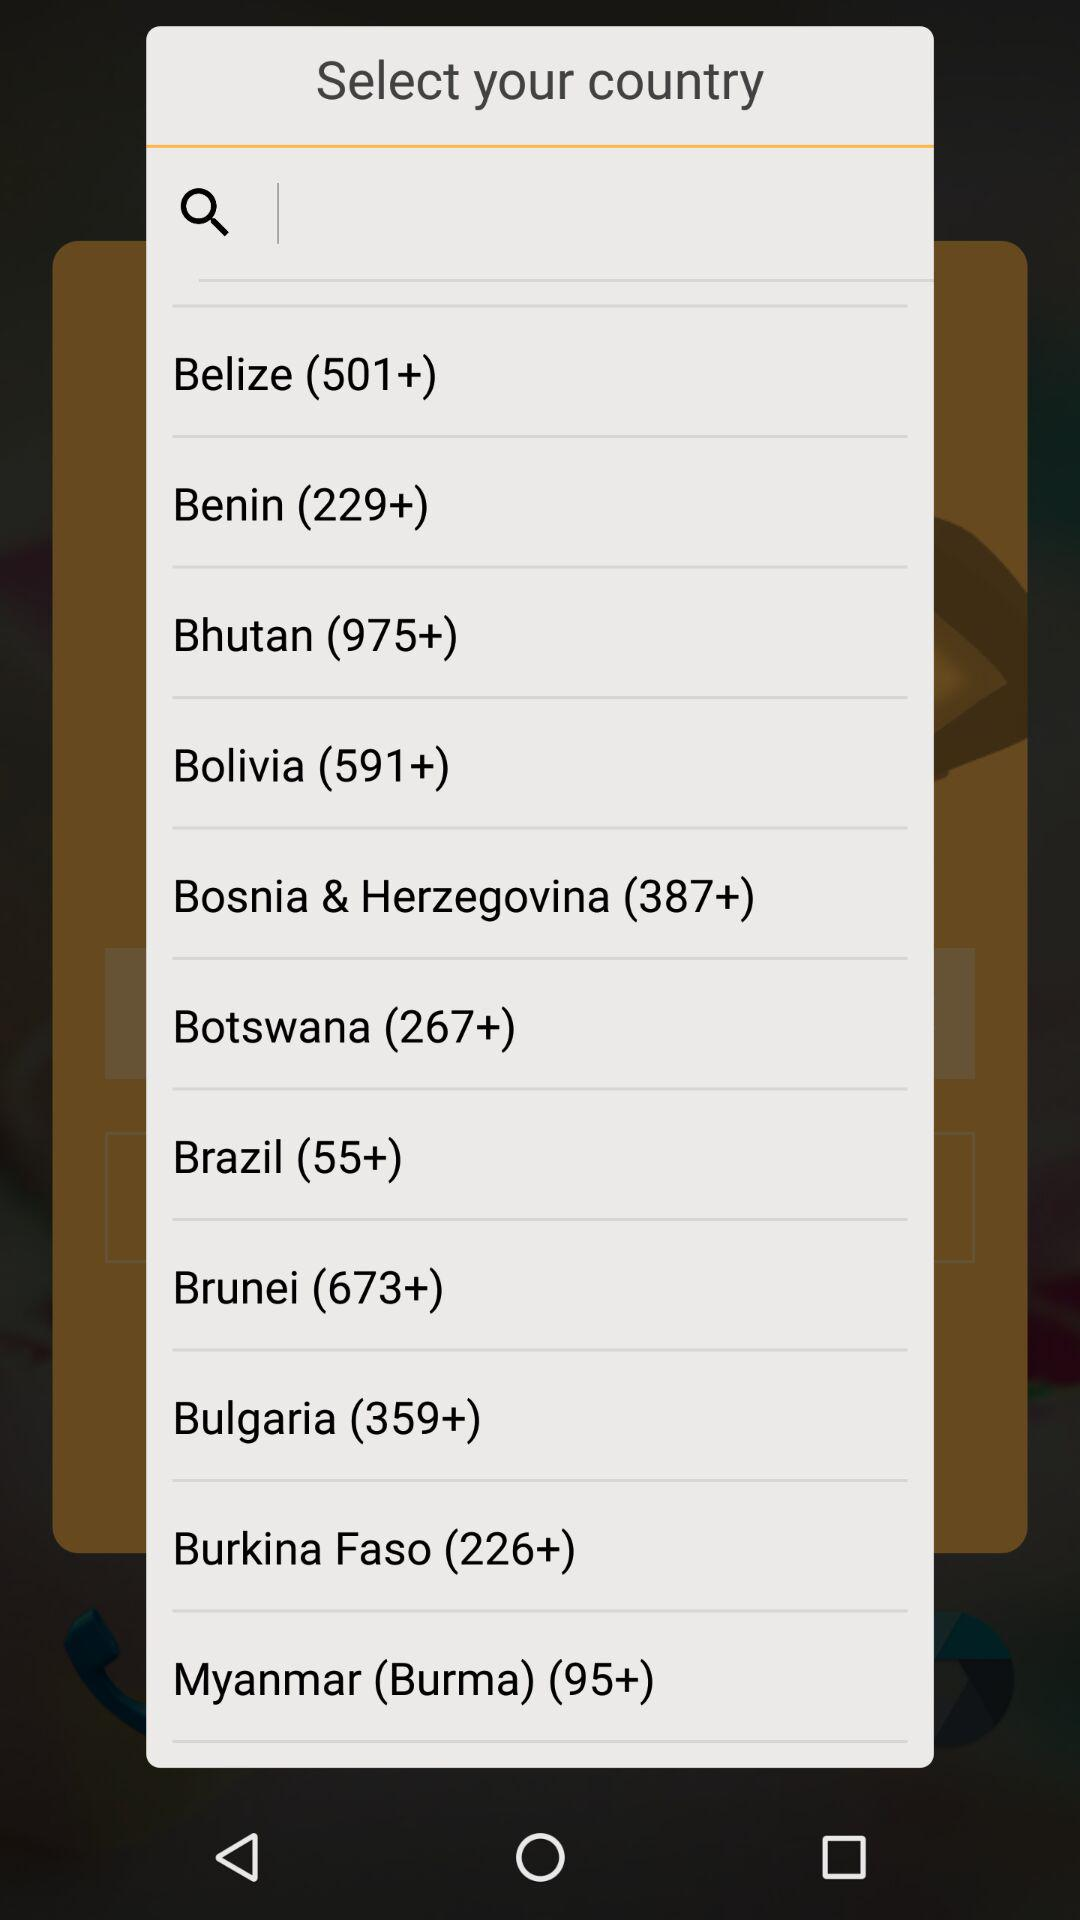What is the user's selected country?
When the provided information is insufficient, respond with <no answer>. <no answer> 